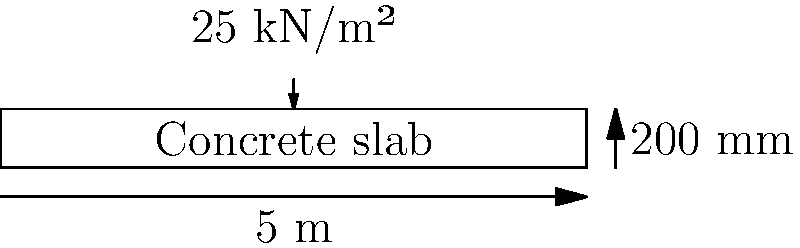During your lunch break, you decide to review some civil engineering concepts. Consider a simply supported concrete slab with a span of 5 m and a thickness of 200 mm. The slab is subjected to a uniformly distributed load of 25 kN/m². Assuming the concrete strength $f_{ck} = 30$ MPa and steel yield strength $f_{yk} = 500$ MPa, calculate the required area of tension reinforcement per meter width of the slab. Use the simplified rectangular stress block method and ignore any compression reinforcement. Let's break this down step-by-step:

1) Calculate the design moment:
   $M_d = \frac{wL^2}{8} = \frac{25 \times 5^2}{8} = 78.125$ kNm/m

2) Determine effective depth (d):
   Assume 25 mm cover and 10 mm bars
   $d = 200 - 25 - 5 = 170$ mm

3) Calculate the lever arm (z):
   Assume $z = 0.9d = 0.9 \times 170 = 153$ mm

4) Calculate required area of steel:
   $A_s = \frac{M_d}{0.87f_{yk}z} = \frac{78.125 \times 10^6}{0.87 \times 500 \times 153} = 1172$ mm²/m

5) Check if assumption of $z = 0.9d$ is valid:
   $K = \frac{M_d}{bd^2f_{ck}} = \frac{78.125 \times 10^6}{1000 \times 170^2 \times 30} = 0.090$
   
   This is less than $K' = 0.168$ for $f_{yk} = 500$ MPa, so the assumption is valid.

Therefore, the required area of tension reinforcement is 1172 mm²/m.
Answer: 1172 mm²/m 